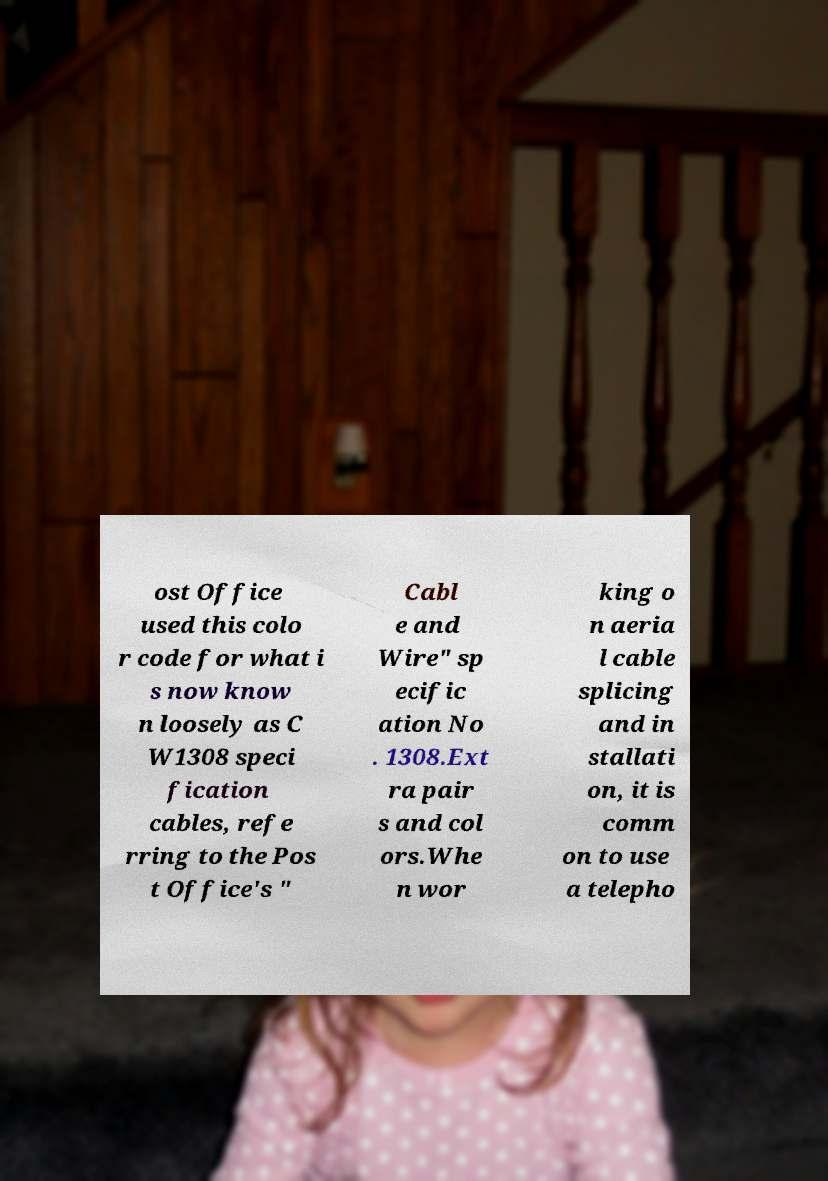For documentation purposes, I need the text within this image transcribed. Could you provide that? ost Office used this colo r code for what i s now know n loosely as C W1308 speci fication cables, refe rring to the Pos t Office's " Cabl e and Wire" sp ecific ation No . 1308.Ext ra pair s and col ors.Whe n wor king o n aeria l cable splicing and in stallati on, it is comm on to use a telepho 